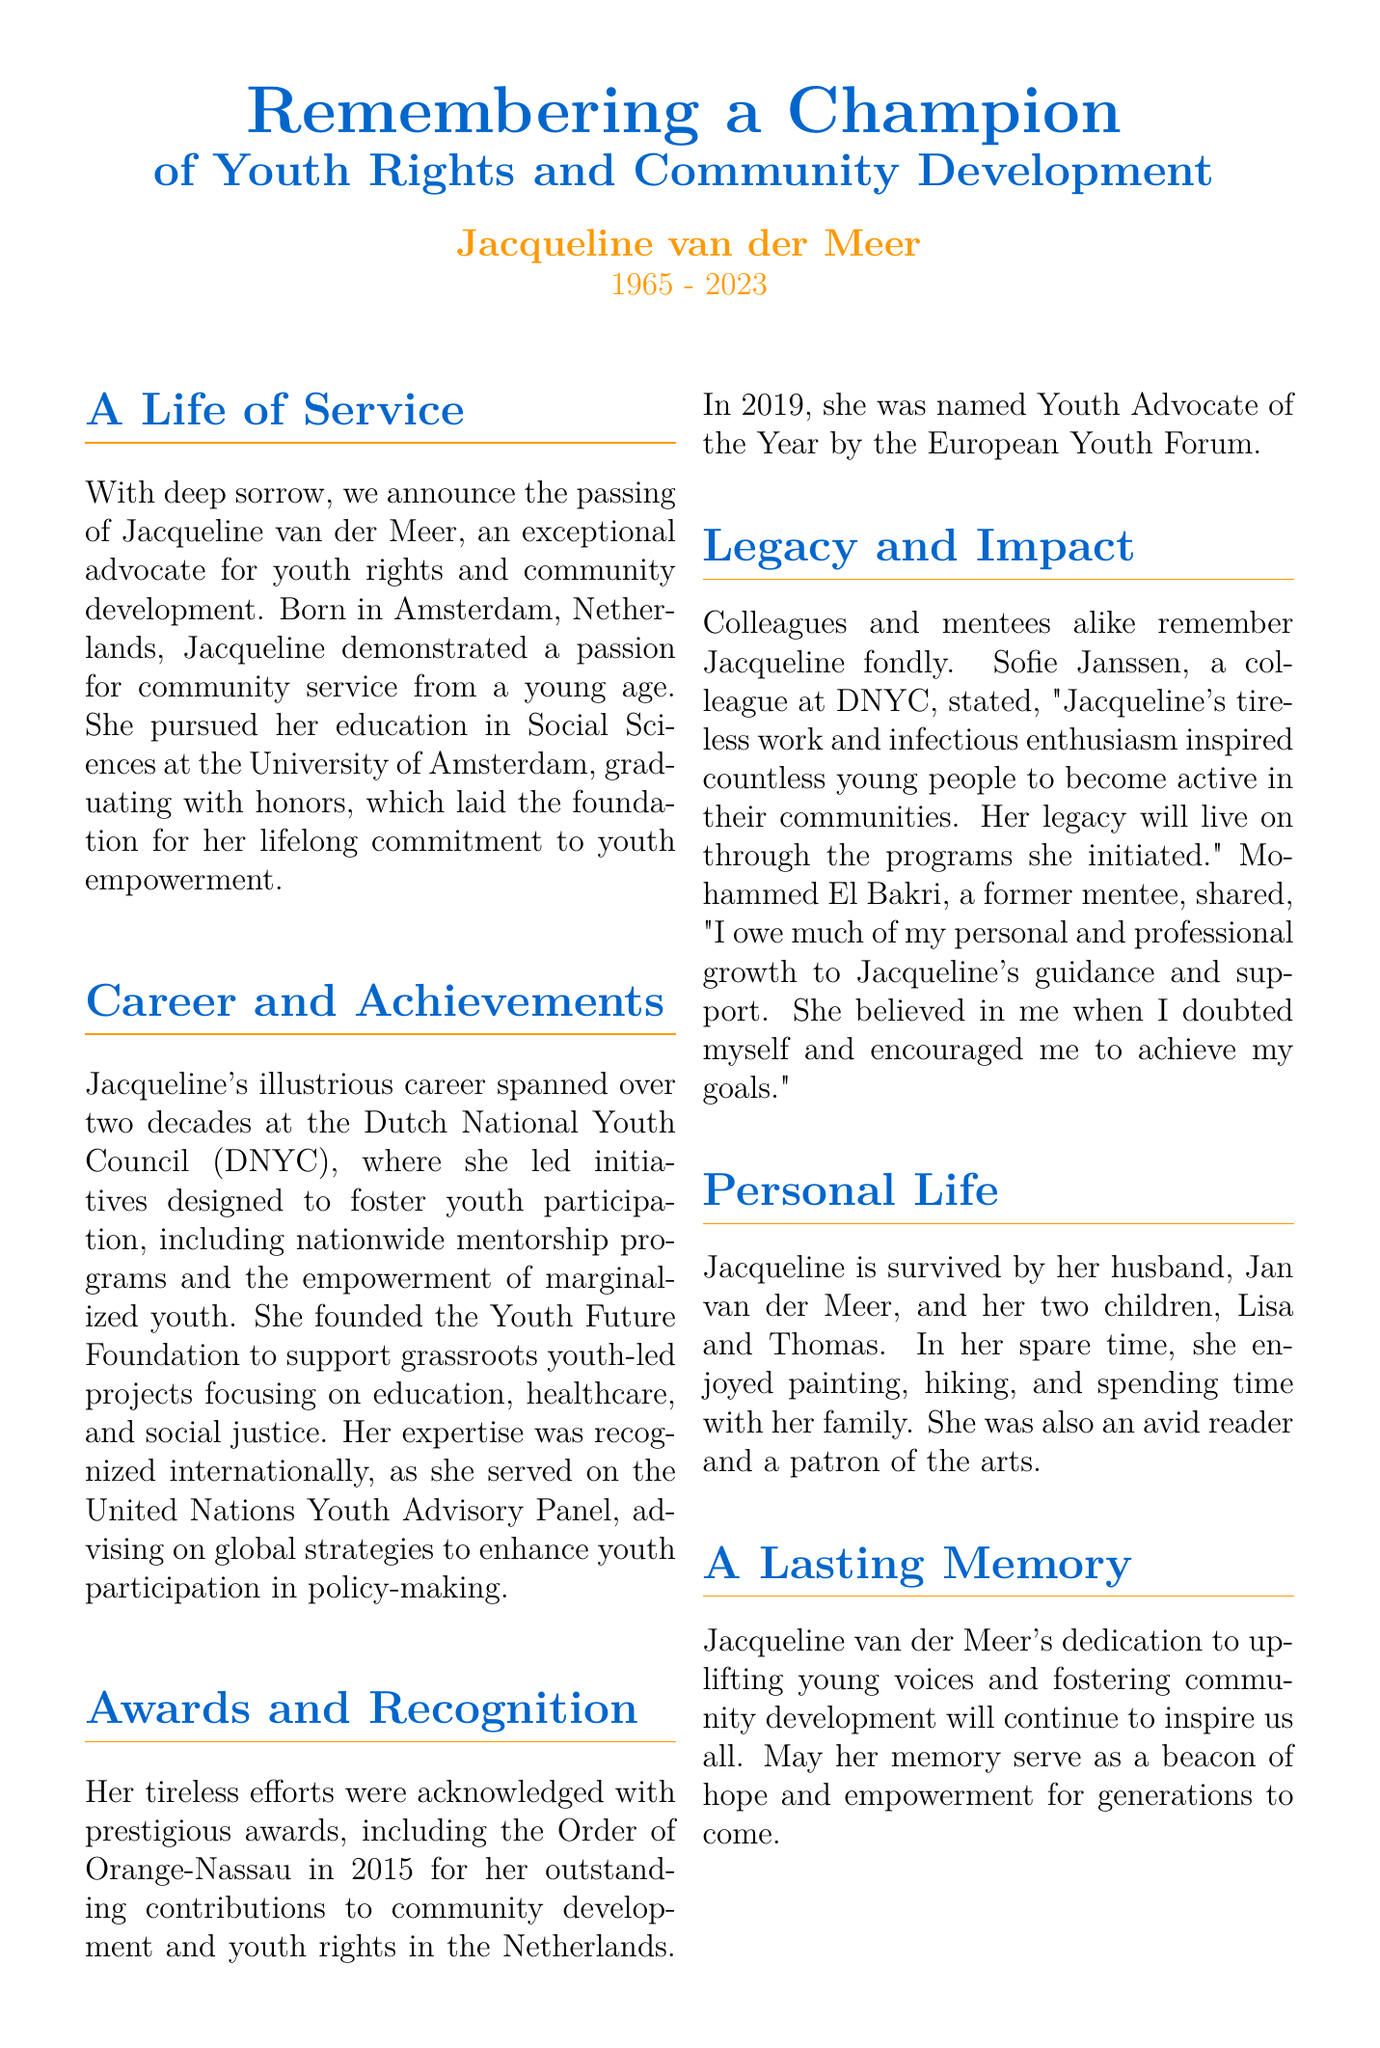What was Jacqueline van der Meer's birth year? The document states that Jacqueline van der Meer was born in 1965.
Answer: 1965 Where did Jacqueline pursue her education? The document mentions that Jacqueline pursued her education in Social Sciences at the University of Amsterdam.
Answer: University of Amsterdam What recognition did Jacqueline receive in 2015? The document indicates that Jacqueline was awarded the Order of Orange-Nassau in 2015.
Answer: Order of Orange-Nassau How many children did Jacqueline have? The document states that Jacqueline is survived by her two children, Lisa and Thomas.
Answer: Two What was the name of the foundation Jacqueline founded? The document mentions that she founded the Youth Future Foundation.
Answer: Youth Future Foundation What did Sofie Janssen say about Jacqueline? The document states that Sofie Janssen said Jacqueline's work and enthusiasm inspired countless young people.
Answer: Inspired countless young people What role did Jacqueline serve on for the United Nations? The document notes that she served on the United Nations Youth Advisory Panel.
Answer: United Nations Youth Advisory Panel What hobbies did Jacqueline enjoy in her spare time? The document lists her hobbies as painting, hiking, and spending time with her family.
Answer: Painting, hiking, and spending time with family Who is Jacqueline's husband? The document mentions that Jacqueline's husband's name is Jan van der Meer.
Answer: Jan van der Meer 